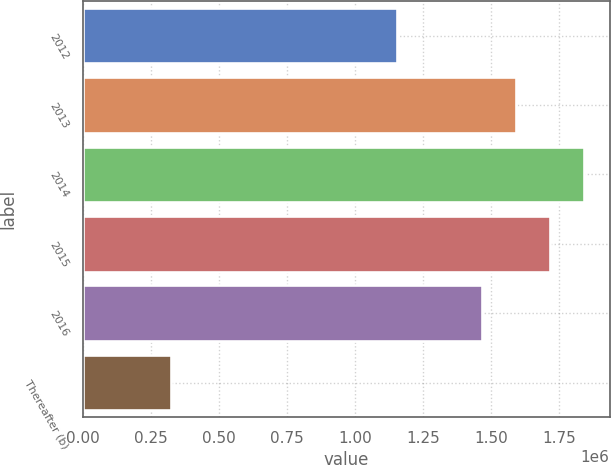Convert chart. <chart><loc_0><loc_0><loc_500><loc_500><bar_chart><fcel>2012<fcel>2013<fcel>2014<fcel>2015<fcel>2016<fcel>Thereafter (b)<nl><fcel>1.1524e+06<fcel>1.59198e+06<fcel>1.84313e+06<fcel>1.71756e+06<fcel>1.46641e+06<fcel>321791<nl></chart> 